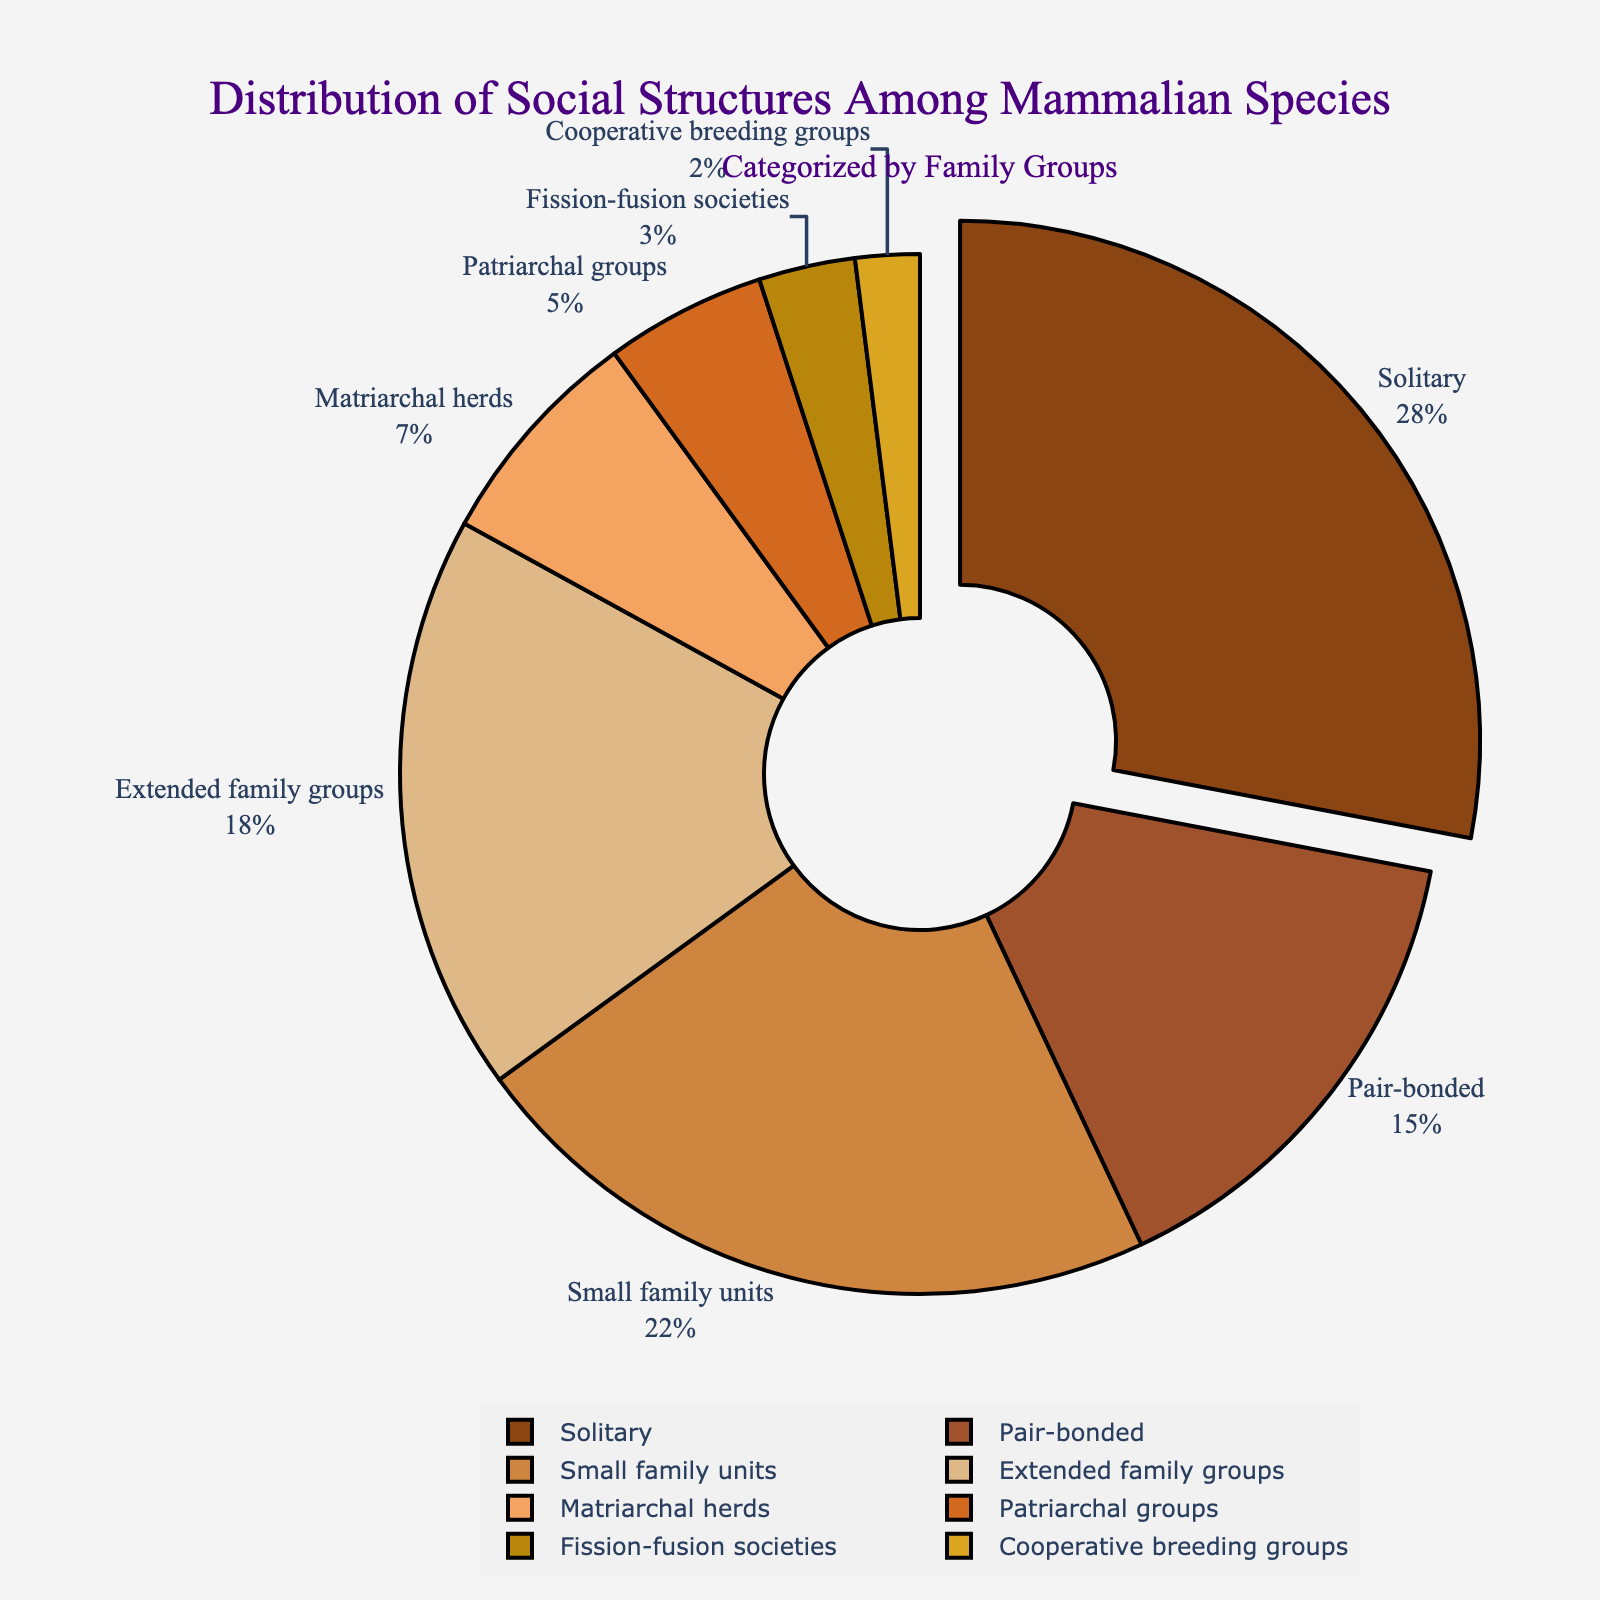What is the largest family group by percentage? The figure shows the largest slice of the pie chart is labeled "Solitary" with its associated percentage shown as 28%.
Answer: Solitary Which family group has the smallest percentage? The smallest slice of the pie chart is labeled "Cooperative breeding groups," and the associated percentage is 2%.
Answer: Cooperative breeding groups What is the combined percentage of "Solitary" and "Pair-bonded" social structures? The percentage for "Solitary" is 28%, and for "Pair-bonded" is 15%. Adding them together gives 28% + 15% = 43%.
Answer: 43% How does the percentage of "Small family units" compare to that of "Extended family groups"? The percentage for "Small family units" is 22%, while for "Extended family groups" is 18%. Comparing them, 22% is greater than 18%.
Answer: Greater Which family group is highlighted more prominently in the pie chart? The 'Solitary' group is highlighted by being slightly pulled out from the rest of the pie chart, indicating it has the largest percentage.
Answer: Solitary What is the total percentage of family groups with less than 10% representation? The slices representing less than 10% are "Matriarchal herds" (7%), "Patriarchal groups" (5%), "Fission-fusion societies" (3%), and "Cooperative breeding groups" (2%). The total is 7% + 5% + 3% + 2% = 17%.
Answer: 17% What is the percentage difference between "Matriarchal herds" and "Patriarchal groups"? The percentage for "Matriarchal herds" is 7%, and for "Patriarchal groups" is 5%. The difference is 7% - 5% = 2%.
Answer: 2% Which color is used to represent "Extended family groups"? The slice for "Extended family groups" is color-coded using a pattern visible in the figure.
Answer: #F4A460 (SandyBrown in natural language) How many family groups have a percentage greater than 20%? The family groups greater than 20% are "Solitary" (28%) and "Small family units" (22%). Counting these gives us 2 groups.
Answer: 2 